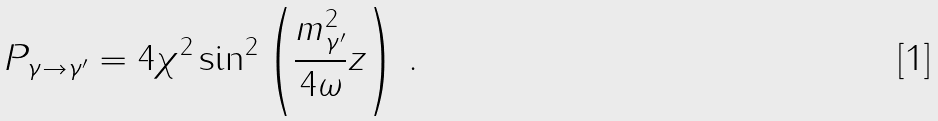Convert formula to latex. <formula><loc_0><loc_0><loc_500><loc_500>P _ { \gamma \to \gamma ^ { \prime } } = 4 \chi ^ { 2 } \sin ^ { 2 } \left ( \frac { m _ { \gamma ^ { \prime } } ^ { 2 } } { 4 \omega } z \right ) \, .</formula> 